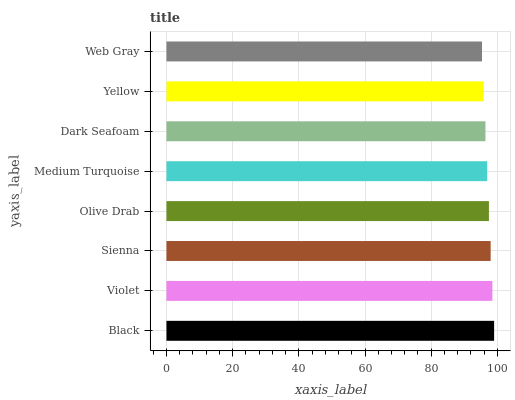Is Web Gray the minimum?
Answer yes or no. Yes. Is Black the maximum?
Answer yes or no. Yes. Is Violet the minimum?
Answer yes or no. No. Is Violet the maximum?
Answer yes or no. No. Is Black greater than Violet?
Answer yes or no. Yes. Is Violet less than Black?
Answer yes or no. Yes. Is Violet greater than Black?
Answer yes or no. No. Is Black less than Violet?
Answer yes or no. No. Is Olive Drab the high median?
Answer yes or no. Yes. Is Medium Turquoise the low median?
Answer yes or no. Yes. Is Dark Seafoam the high median?
Answer yes or no. No. Is Sienna the low median?
Answer yes or no. No. 